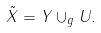<formula> <loc_0><loc_0><loc_500><loc_500>\tilde { X } = Y \cup _ { g } U .</formula> 